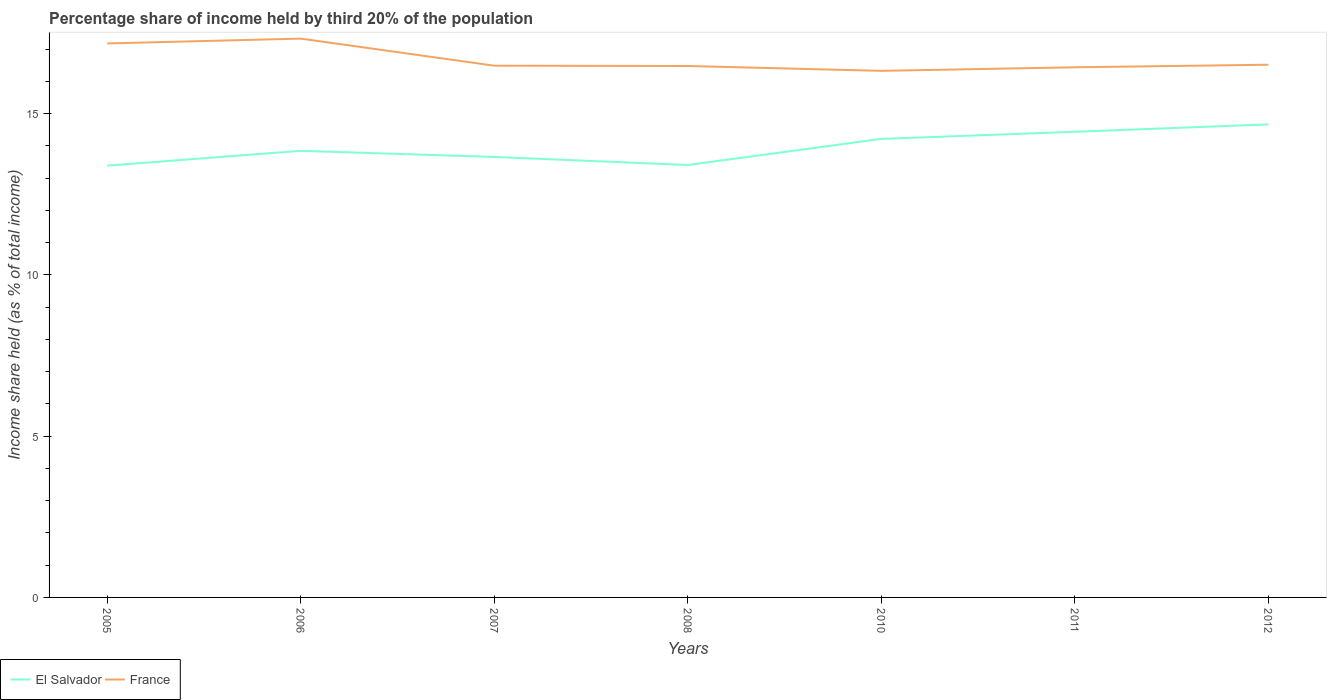How many different coloured lines are there?
Offer a terse response. 2. Does the line corresponding to El Salvador intersect with the line corresponding to France?
Offer a very short reply. No. Across all years, what is the maximum share of income held by third 20% of the population in France?
Ensure brevity in your answer.  16.33. In which year was the share of income held by third 20% of the population in El Salvador maximum?
Offer a very short reply. 2005. What is the total share of income held by third 20% of the population in France in the graph?
Your response must be concise. -0.15. How many years are there in the graph?
Offer a very short reply. 7. Where does the legend appear in the graph?
Offer a very short reply. Bottom left. How many legend labels are there?
Keep it short and to the point. 2. How are the legend labels stacked?
Provide a short and direct response. Horizontal. What is the title of the graph?
Keep it short and to the point. Percentage share of income held by third 20% of the population. What is the label or title of the Y-axis?
Provide a succinct answer. Income share held (as % of total income). What is the Income share held (as % of total income) in El Salvador in 2005?
Provide a short and direct response. 13.39. What is the Income share held (as % of total income) in France in 2005?
Provide a short and direct response. 17.18. What is the Income share held (as % of total income) in El Salvador in 2006?
Make the answer very short. 13.85. What is the Income share held (as % of total income) of France in 2006?
Your response must be concise. 17.33. What is the Income share held (as % of total income) of El Salvador in 2007?
Give a very brief answer. 13.66. What is the Income share held (as % of total income) of France in 2007?
Keep it short and to the point. 16.49. What is the Income share held (as % of total income) of El Salvador in 2008?
Your answer should be compact. 13.41. What is the Income share held (as % of total income) of France in 2008?
Your answer should be compact. 16.48. What is the Income share held (as % of total income) of El Salvador in 2010?
Keep it short and to the point. 14.22. What is the Income share held (as % of total income) in France in 2010?
Ensure brevity in your answer.  16.33. What is the Income share held (as % of total income) in El Salvador in 2011?
Ensure brevity in your answer.  14.44. What is the Income share held (as % of total income) in France in 2011?
Provide a short and direct response. 16.44. What is the Income share held (as % of total income) in El Salvador in 2012?
Offer a very short reply. 14.67. What is the Income share held (as % of total income) in France in 2012?
Your response must be concise. 16.52. Across all years, what is the maximum Income share held (as % of total income) in El Salvador?
Keep it short and to the point. 14.67. Across all years, what is the maximum Income share held (as % of total income) in France?
Your answer should be compact. 17.33. Across all years, what is the minimum Income share held (as % of total income) in El Salvador?
Offer a terse response. 13.39. Across all years, what is the minimum Income share held (as % of total income) of France?
Provide a succinct answer. 16.33. What is the total Income share held (as % of total income) of El Salvador in the graph?
Your response must be concise. 97.64. What is the total Income share held (as % of total income) in France in the graph?
Your answer should be very brief. 116.77. What is the difference between the Income share held (as % of total income) in El Salvador in 2005 and that in 2006?
Offer a terse response. -0.46. What is the difference between the Income share held (as % of total income) in El Salvador in 2005 and that in 2007?
Your answer should be very brief. -0.27. What is the difference between the Income share held (as % of total income) of France in 2005 and that in 2007?
Provide a succinct answer. 0.69. What is the difference between the Income share held (as % of total income) in El Salvador in 2005 and that in 2008?
Your answer should be compact. -0.02. What is the difference between the Income share held (as % of total income) of El Salvador in 2005 and that in 2010?
Your response must be concise. -0.83. What is the difference between the Income share held (as % of total income) in El Salvador in 2005 and that in 2011?
Provide a short and direct response. -1.05. What is the difference between the Income share held (as % of total income) in France in 2005 and that in 2011?
Provide a short and direct response. 0.74. What is the difference between the Income share held (as % of total income) in El Salvador in 2005 and that in 2012?
Ensure brevity in your answer.  -1.28. What is the difference between the Income share held (as % of total income) of France in 2005 and that in 2012?
Make the answer very short. 0.66. What is the difference between the Income share held (as % of total income) in El Salvador in 2006 and that in 2007?
Ensure brevity in your answer.  0.19. What is the difference between the Income share held (as % of total income) in France in 2006 and that in 2007?
Make the answer very short. 0.84. What is the difference between the Income share held (as % of total income) of El Salvador in 2006 and that in 2008?
Ensure brevity in your answer.  0.44. What is the difference between the Income share held (as % of total income) in El Salvador in 2006 and that in 2010?
Your answer should be compact. -0.37. What is the difference between the Income share held (as % of total income) of El Salvador in 2006 and that in 2011?
Offer a very short reply. -0.59. What is the difference between the Income share held (as % of total income) of France in 2006 and that in 2011?
Provide a succinct answer. 0.89. What is the difference between the Income share held (as % of total income) in El Salvador in 2006 and that in 2012?
Give a very brief answer. -0.82. What is the difference between the Income share held (as % of total income) in France in 2006 and that in 2012?
Give a very brief answer. 0.81. What is the difference between the Income share held (as % of total income) in France in 2007 and that in 2008?
Your response must be concise. 0.01. What is the difference between the Income share held (as % of total income) in El Salvador in 2007 and that in 2010?
Give a very brief answer. -0.56. What is the difference between the Income share held (as % of total income) in France in 2007 and that in 2010?
Give a very brief answer. 0.16. What is the difference between the Income share held (as % of total income) in El Salvador in 2007 and that in 2011?
Give a very brief answer. -0.78. What is the difference between the Income share held (as % of total income) in France in 2007 and that in 2011?
Keep it short and to the point. 0.05. What is the difference between the Income share held (as % of total income) of El Salvador in 2007 and that in 2012?
Make the answer very short. -1.01. What is the difference between the Income share held (as % of total income) in France in 2007 and that in 2012?
Keep it short and to the point. -0.03. What is the difference between the Income share held (as % of total income) in El Salvador in 2008 and that in 2010?
Provide a short and direct response. -0.81. What is the difference between the Income share held (as % of total income) of El Salvador in 2008 and that in 2011?
Provide a succinct answer. -1.03. What is the difference between the Income share held (as % of total income) in France in 2008 and that in 2011?
Keep it short and to the point. 0.04. What is the difference between the Income share held (as % of total income) of El Salvador in 2008 and that in 2012?
Provide a short and direct response. -1.26. What is the difference between the Income share held (as % of total income) of France in 2008 and that in 2012?
Make the answer very short. -0.04. What is the difference between the Income share held (as % of total income) of El Salvador in 2010 and that in 2011?
Provide a short and direct response. -0.22. What is the difference between the Income share held (as % of total income) in France in 2010 and that in 2011?
Offer a terse response. -0.11. What is the difference between the Income share held (as % of total income) in El Salvador in 2010 and that in 2012?
Your answer should be very brief. -0.45. What is the difference between the Income share held (as % of total income) in France in 2010 and that in 2012?
Provide a short and direct response. -0.19. What is the difference between the Income share held (as % of total income) of El Salvador in 2011 and that in 2012?
Offer a terse response. -0.23. What is the difference between the Income share held (as % of total income) in France in 2011 and that in 2012?
Provide a short and direct response. -0.08. What is the difference between the Income share held (as % of total income) in El Salvador in 2005 and the Income share held (as % of total income) in France in 2006?
Offer a very short reply. -3.94. What is the difference between the Income share held (as % of total income) in El Salvador in 2005 and the Income share held (as % of total income) in France in 2007?
Your answer should be very brief. -3.1. What is the difference between the Income share held (as % of total income) in El Salvador in 2005 and the Income share held (as % of total income) in France in 2008?
Ensure brevity in your answer.  -3.09. What is the difference between the Income share held (as % of total income) of El Salvador in 2005 and the Income share held (as % of total income) of France in 2010?
Keep it short and to the point. -2.94. What is the difference between the Income share held (as % of total income) in El Salvador in 2005 and the Income share held (as % of total income) in France in 2011?
Provide a short and direct response. -3.05. What is the difference between the Income share held (as % of total income) of El Salvador in 2005 and the Income share held (as % of total income) of France in 2012?
Offer a very short reply. -3.13. What is the difference between the Income share held (as % of total income) of El Salvador in 2006 and the Income share held (as % of total income) of France in 2007?
Give a very brief answer. -2.64. What is the difference between the Income share held (as % of total income) of El Salvador in 2006 and the Income share held (as % of total income) of France in 2008?
Make the answer very short. -2.63. What is the difference between the Income share held (as % of total income) of El Salvador in 2006 and the Income share held (as % of total income) of France in 2010?
Provide a short and direct response. -2.48. What is the difference between the Income share held (as % of total income) of El Salvador in 2006 and the Income share held (as % of total income) of France in 2011?
Provide a succinct answer. -2.59. What is the difference between the Income share held (as % of total income) of El Salvador in 2006 and the Income share held (as % of total income) of France in 2012?
Your answer should be very brief. -2.67. What is the difference between the Income share held (as % of total income) in El Salvador in 2007 and the Income share held (as % of total income) in France in 2008?
Give a very brief answer. -2.82. What is the difference between the Income share held (as % of total income) in El Salvador in 2007 and the Income share held (as % of total income) in France in 2010?
Ensure brevity in your answer.  -2.67. What is the difference between the Income share held (as % of total income) in El Salvador in 2007 and the Income share held (as % of total income) in France in 2011?
Provide a short and direct response. -2.78. What is the difference between the Income share held (as % of total income) of El Salvador in 2007 and the Income share held (as % of total income) of France in 2012?
Your answer should be compact. -2.86. What is the difference between the Income share held (as % of total income) of El Salvador in 2008 and the Income share held (as % of total income) of France in 2010?
Offer a terse response. -2.92. What is the difference between the Income share held (as % of total income) of El Salvador in 2008 and the Income share held (as % of total income) of France in 2011?
Ensure brevity in your answer.  -3.03. What is the difference between the Income share held (as % of total income) in El Salvador in 2008 and the Income share held (as % of total income) in France in 2012?
Keep it short and to the point. -3.11. What is the difference between the Income share held (as % of total income) in El Salvador in 2010 and the Income share held (as % of total income) in France in 2011?
Provide a short and direct response. -2.22. What is the difference between the Income share held (as % of total income) in El Salvador in 2011 and the Income share held (as % of total income) in France in 2012?
Make the answer very short. -2.08. What is the average Income share held (as % of total income) in El Salvador per year?
Ensure brevity in your answer.  13.95. What is the average Income share held (as % of total income) of France per year?
Make the answer very short. 16.68. In the year 2005, what is the difference between the Income share held (as % of total income) of El Salvador and Income share held (as % of total income) of France?
Offer a very short reply. -3.79. In the year 2006, what is the difference between the Income share held (as % of total income) in El Salvador and Income share held (as % of total income) in France?
Give a very brief answer. -3.48. In the year 2007, what is the difference between the Income share held (as % of total income) in El Salvador and Income share held (as % of total income) in France?
Offer a terse response. -2.83. In the year 2008, what is the difference between the Income share held (as % of total income) in El Salvador and Income share held (as % of total income) in France?
Make the answer very short. -3.07. In the year 2010, what is the difference between the Income share held (as % of total income) in El Salvador and Income share held (as % of total income) in France?
Make the answer very short. -2.11. In the year 2012, what is the difference between the Income share held (as % of total income) in El Salvador and Income share held (as % of total income) in France?
Offer a terse response. -1.85. What is the ratio of the Income share held (as % of total income) of El Salvador in 2005 to that in 2006?
Make the answer very short. 0.97. What is the ratio of the Income share held (as % of total income) in El Salvador in 2005 to that in 2007?
Keep it short and to the point. 0.98. What is the ratio of the Income share held (as % of total income) in France in 2005 to that in 2007?
Offer a very short reply. 1.04. What is the ratio of the Income share held (as % of total income) of France in 2005 to that in 2008?
Your answer should be compact. 1.04. What is the ratio of the Income share held (as % of total income) of El Salvador in 2005 to that in 2010?
Keep it short and to the point. 0.94. What is the ratio of the Income share held (as % of total income) in France in 2005 to that in 2010?
Make the answer very short. 1.05. What is the ratio of the Income share held (as % of total income) of El Salvador in 2005 to that in 2011?
Provide a succinct answer. 0.93. What is the ratio of the Income share held (as % of total income) of France in 2005 to that in 2011?
Provide a short and direct response. 1.04. What is the ratio of the Income share held (as % of total income) of El Salvador in 2005 to that in 2012?
Your response must be concise. 0.91. What is the ratio of the Income share held (as % of total income) of El Salvador in 2006 to that in 2007?
Make the answer very short. 1.01. What is the ratio of the Income share held (as % of total income) in France in 2006 to that in 2007?
Offer a very short reply. 1.05. What is the ratio of the Income share held (as % of total income) in El Salvador in 2006 to that in 2008?
Your response must be concise. 1.03. What is the ratio of the Income share held (as % of total income) in France in 2006 to that in 2008?
Ensure brevity in your answer.  1.05. What is the ratio of the Income share held (as % of total income) of El Salvador in 2006 to that in 2010?
Offer a terse response. 0.97. What is the ratio of the Income share held (as % of total income) in France in 2006 to that in 2010?
Your answer should be very brief. 1.06. What is the ratio of the Income share held (as % of total income) in El Salvador in 2006 to that in 2011?
Make the answer very short. 0.96. What is the ratio of the Income share held (as % of total income) in France in 2006 to that in 2011?
Provide a succinct answer. 1.05. What is the ratio of the Income share held (as % of total income) of El Salvador in 2006 to that in 2012?
Give a very brief answer. 0.94. What is the ratio of the Income share held (as % of total income) of France in 2006 to that in 2012?
Your response must be concise. 1.05. What is the ratio of the Income share held (as % of total income) in El Salvador in 2007 to that in 2008?
Offer a terse response. 1.02. What is the ratio of the Income share held (as % of total income) in El Salvador in 2007 to that in 2010?
Make the answer very short. 0.96. What is the ratio of the Income share held (as % of total income) of France in 2007 to that in 2010?
Keep it short and to the point. 1.01. What is the ratio of the Income share held (as % of total income) in El Salvador in 2007 to that in 2011?
Your answer should be compact. 0.95. What is the ratio of the Income share held (as % of total income) in France in 2007 to that in 2011?
Provide a short and direct response. 1. What is the ratio of the Income share held (as % of total income) in El Salvador in 2007 to that in 2012?
Make the answer very short. 0.93. What is the ratio of the Income share held (as % of total income) in El Salvador in 2008 to that in 2010?
Make the answer very short. 0.94. What is the ratio of the Income share held (as % of total income) in France in 2008 to that in 2010?
Your answer should be very brief. 1.01. What is the ratio of the Income share held (as % of total income) in El Salvador in 2008 to that in 2011?
Your answer should be compact. 0.93. What is the ratio of the Income share held (as % of total income) of El Salvador in 2008 to that in 2012?
Make the answer very short. 0.91. What is the ratio of the Income share held (as % of total income) of France in 2008 to that in 2012?
Offer a very short reply. 1. What is the ratio of the Income share held (as % of total income) in El Salvador in 2010 to that in 2012?
Your answer should be compact. 0.97. What is the ratio of the Income share held (as % of total income) of France in 2010 to that in 2012?
Provide a succinct answer. 0.99. What is the ratio of the Income share held (as % of total income) in El Salvador in 2011 to that in 2012?
Your response must be concise. 0.98. What is the difference between the highest and the second highest Income share held (as % of total income) in El Salvador?
Your answer should be compact. 0.23. What is the difference between the highest and the second highest Income share held (as % of total income) of France?
Keep it short and to the point. 0.15. What is the difference between the highest and the lowest Income share held (as % of total income) of El Salvador?
Offer a very short reply. 1.28. What is the difference between the highest and the lowest Income share held (as % of total income) of France?
Provide a short and direct response. 1. 